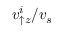Convert formula to latex. <formula><loc_0><loc_0><loc_500><loc_500>v _ { \uparrow z } ^ { i } / v _ { s }</formula> 